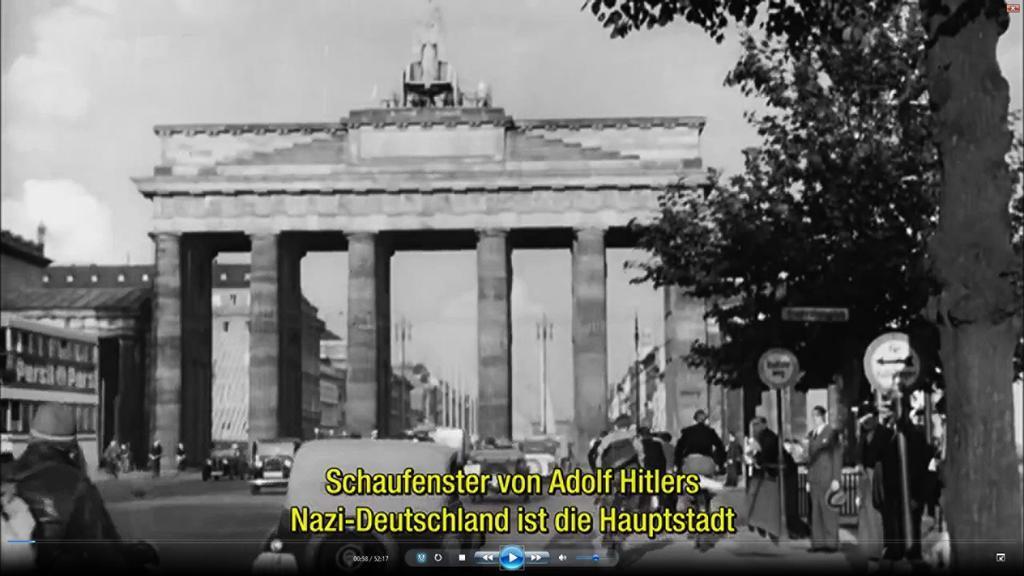Could you give a brief overview of what you see in this image? In this image at the center there is an arch. There are vehicles on the road. On the right side of the image there are sign boards, trees. We can see some text written in front of the image. On the backside there are buildings. In the background there is sky. 